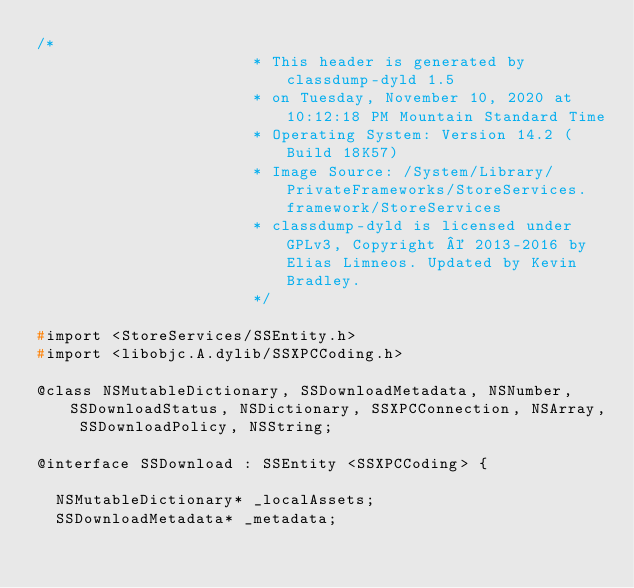Convert code to text. <code><loc_0><loc_0><loc_500><loc_500><_C_>/*
                       * This header is generated by classdump-dyld 1.5
                       * on Tuesday, November 10, 2020 at 10:12:18 PM Mountain Standard Time
                       * Operating System: Version 14.2 (Build 18K57)
                       * Image Source: /System/Library/PrivateFrameworks/StoreServices.framework/StoreServices
                       * classdump-dyld is licensed under GPLv3, Copyright © 2013-2016 by Elias Limneos. Updated by Kevin Bradley.
                       */

#import <StoreServices/SSEntity.h>
#import <libobjc.A.dylib/SSXPCCoding.h>

@class NSMutableDictionary, SSDownloadMetadata, NSNumber, SSDownloadStatus, NSDictionary, SSXPCConnection, NSArray, SSDownloadPolicy, NSString;

@interface SSDownload : SSEntity <SSXPCCoding> {

	NSMutableDictionary* _localAssets;
	SSDownloadMetadata* _metadata;</code> 